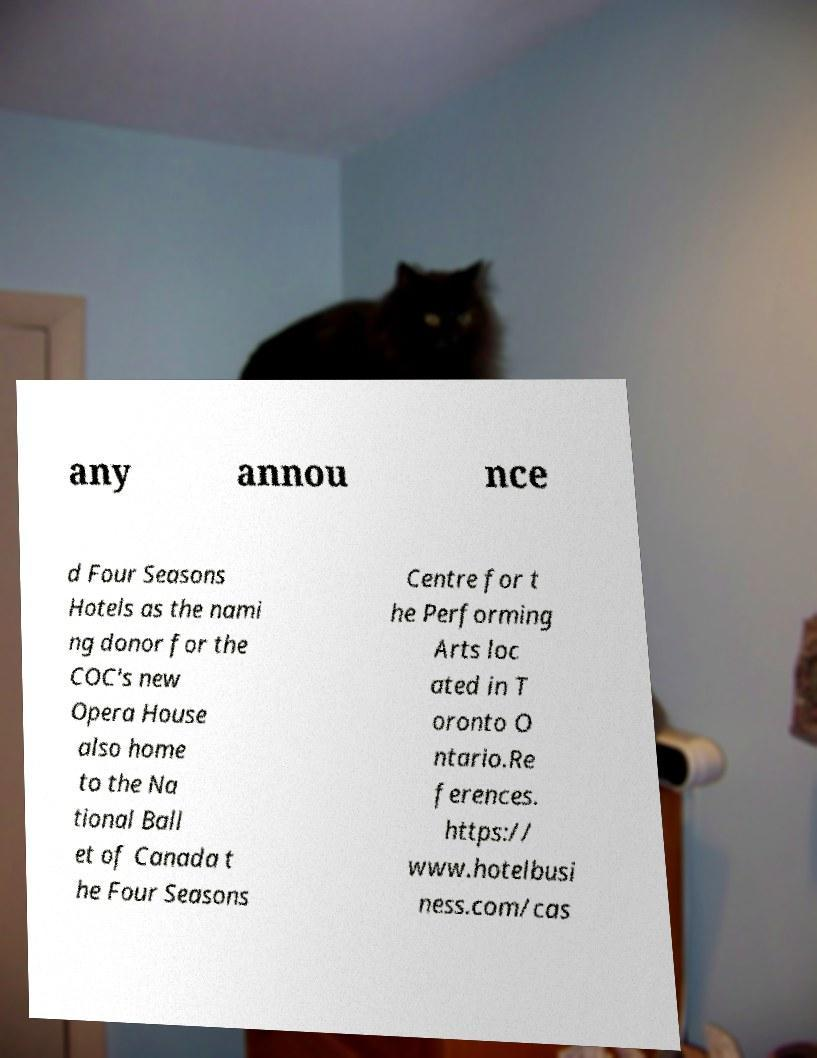For documentation purposes, I need the text within this image transcribed. Could you provide that? any annou nce d Four Seasons Hotels as the nami ng donor for the COC's new Opera House also home to the Na tional Ball et of Canada t he Four Seasons Centre for t he Performing Arts loc ated in T oronto O ntario.Re ferences. https:// www.hotelbusi ness.com/cas 